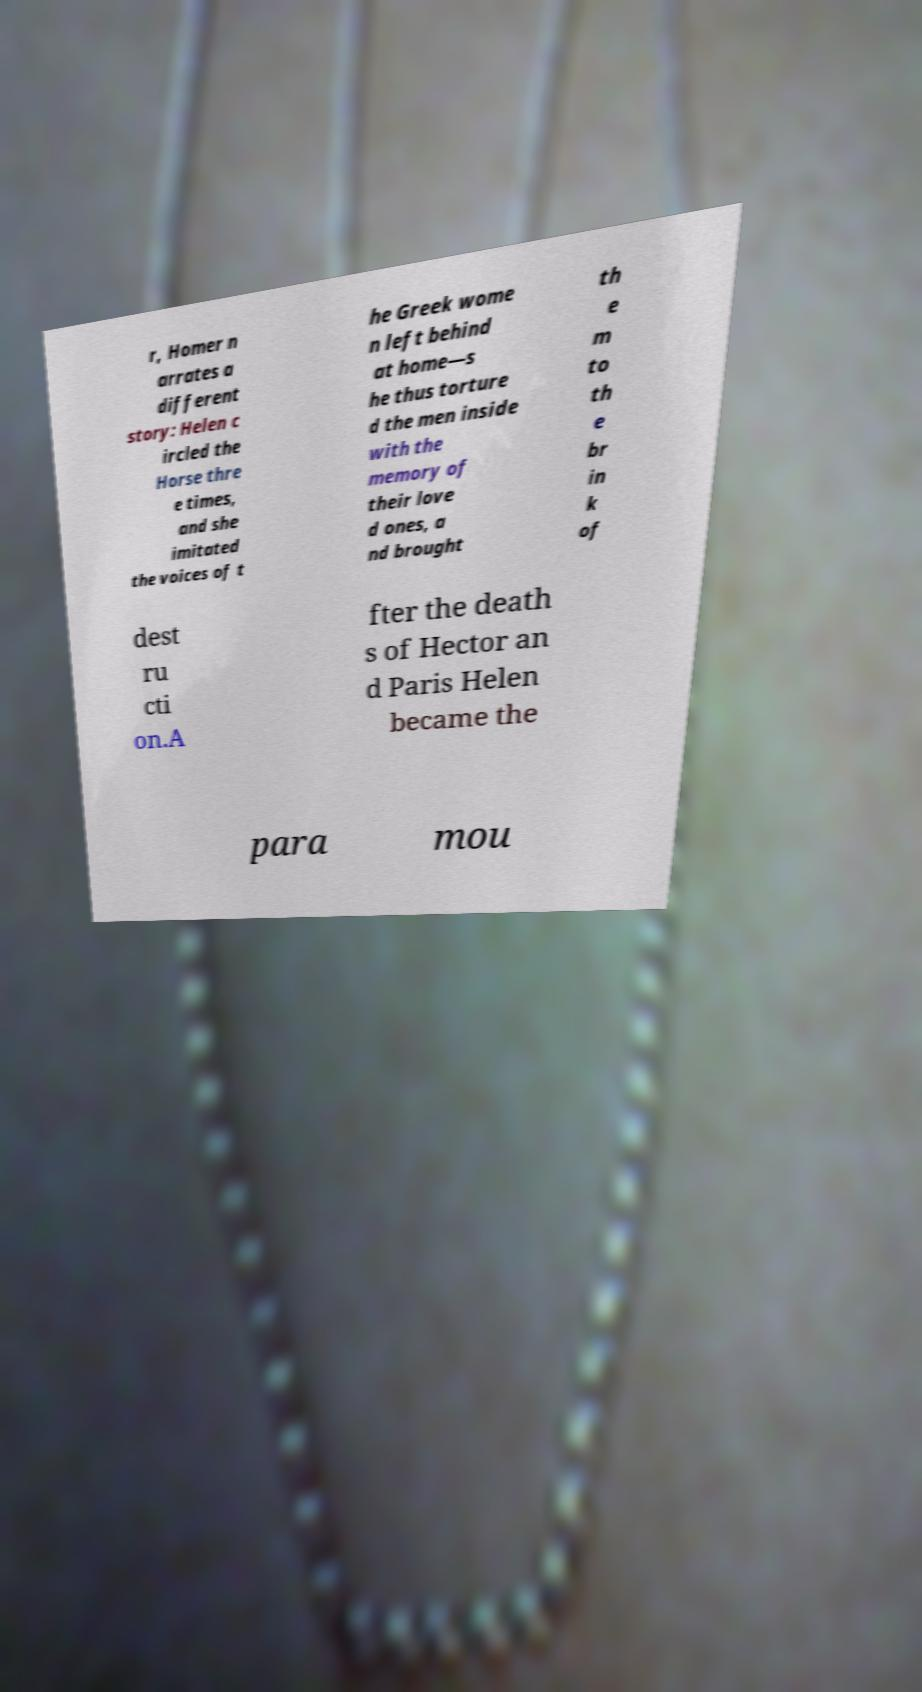Please read and relay the text visible in this image. What does it say? r, Homer n arrates a different story: Helen c ircled the Horse thre e times, and she imitated the voices of t he Greek wome n left behind at home—s he thus torture d the men inside with the memory of their love d ones, a nd brought th e m to th e br in k of dest ru cti on.A fter the death s of Hector an d Paris Helen became the para mou 